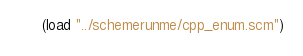Convert code to text. <code><loc_0><loc_0><loc_500><loc_500><_Scheme_>(load "../schemerunme/cpp_enum.scm")
</code> 